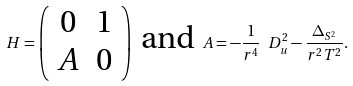<formula> <loc_0><loc_0><loc_500><loc_500>H = \left ( \begin{array} { c c } 0 & 1 \\ A & 0 \end{array} \right ) \text { and } A = - \frac { 1 } { r ^ { 4 } } \ D _ { u } ^ { 2 } - \frac { \Delta _ { S ^ { 2 } } } { r ^ { 2 } T ^ { 2 } } .</formula> 